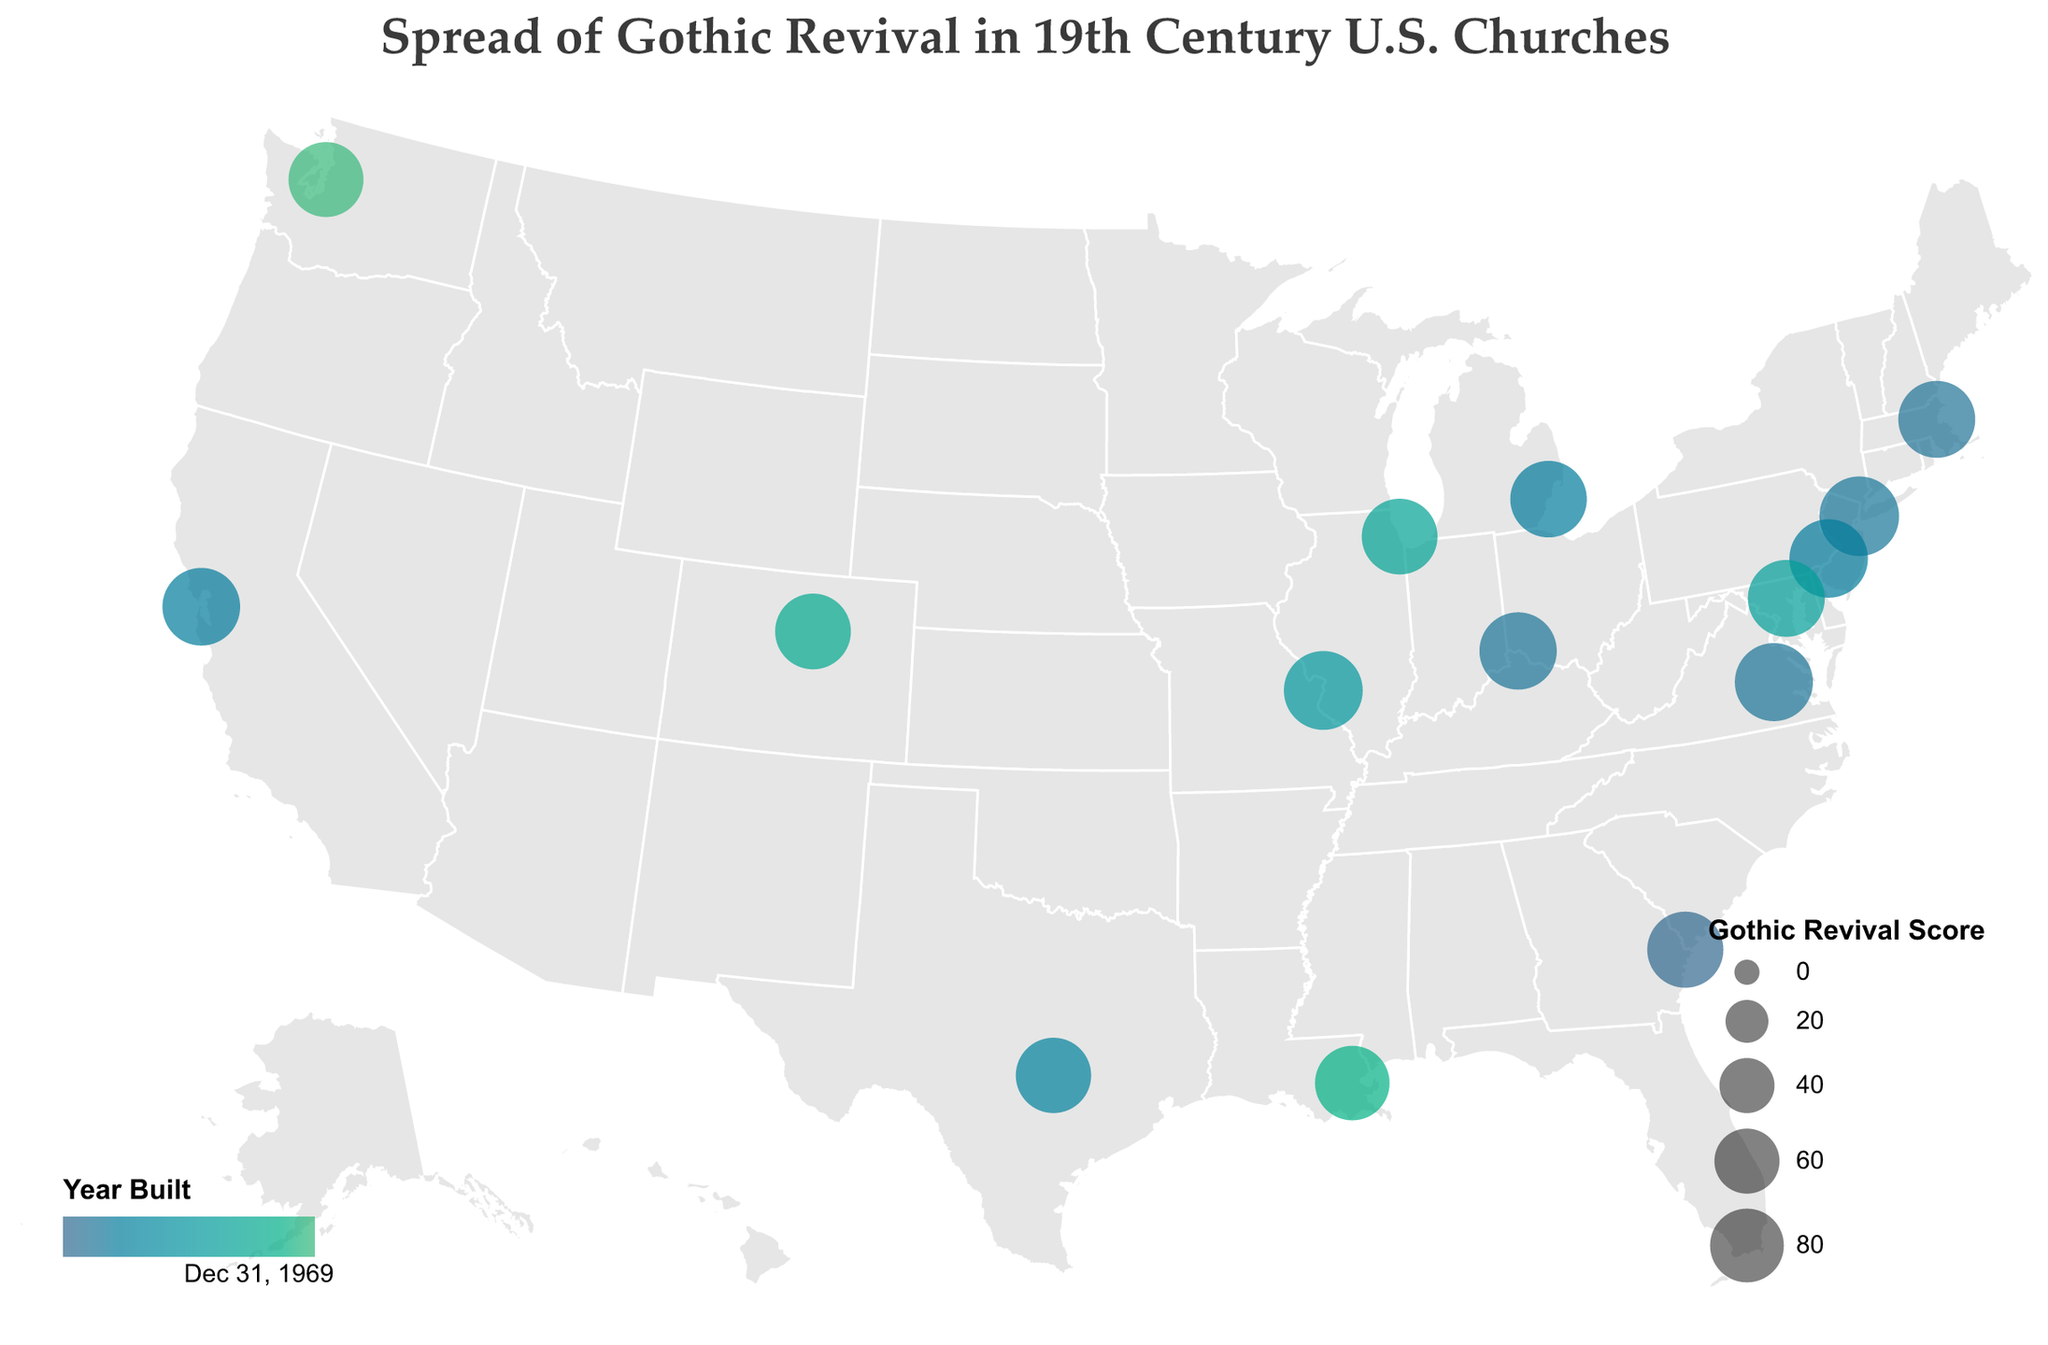What is the title of the figure? The title is displayed at the top center of the figure, showing the main topic or subject of the plot
Answer: Spread of Gothic Revival in 19th Century U.S. Churches How many churches from the state of New York are represented in the plot? The tooltip or labels indicate one church from New York: Trinity Church in New York City
Answer: One Which church has the highest Gothic Revival Score? The tooltip provides information on each church, and the size of the circle correlates with the Gothic Revival Score. The largest circle corresponds to Trinity Church in New York City with a score of 95
Answer: Trinity Church, New York City What is the earliest year listed on the plot? The color gradient legend indicates the years, and the tooltips provide the exact year each church was built. Christ Church in Savannah is shown as being built in 1838, which is the earliest year
Answer: 1838 Which states have churches with a Gothic Revival Score above 90? The tooltips provide Gothic Revival Scores, and we can identify the states with scores above 90 by looking at this detailed information. These are New York (95), Pennsylvania (92), Missouri (93), and Virginia (91)
Answer: New York, Pennsylvania, Missouri, Virginia On the plot, which geographic region (Northeast, South, Midwest, or West) has the most churches with significant Gothic Revival elements? The plot's geographic projection of the United States allows for a visual comparison. By counting the circles within each region, the Northeast (New York, Massachusetts, Pennsylvania, Maryland) shows the most churches with significant scores
Answer: Northeast Compare Illinois and Colorado. Which state has a church with a higher Gothic Revival Score, and what are those scores? By comparing the tooltips for the circles located in Illinois (Holy Name Cathedral, 85) and Colorado (St. John's Cathedral, 85), we see that both have churches with identical scores
Answer: Both states have a score of 85 each What is the average Gothic Revival Score of the churches built before 1850? We first identify churches built before 1850 (Church of the Advent, Trinity Church, St. Peter in Chains Cathedral, St. Paul's Episcopal Church, Mariners' Church, St. Mark's Episcopal Church, and Grace Cathedral). Their scores are 88, 95, 89, 91, 87, 92, and 90. The average is calculated by summing these scores and dividing by the number of churches: (88 + 95 + 89 + 91 + 87 + 92 + 90) / 7 = 90.29
Answer: 90.29 Which church in the Western United States (west of the Mississippi River) has the latest construction year? Identifying western states (California, Colorado, Washington), we check the years: Grace Cathedral (1849), St. John's Cathedral (1880), and Trinity Parish Church (1892) in Seattle
Answer: Trinity Parish Church, Seattle Which city has the highest concentration of churches with Gothic Revival elements according to the plot? The plot shows individual data points (circles) for each church. Only one church is shown per city on the figure, indicating no city has more than one church represented
Answer: No city has a higher concentration 